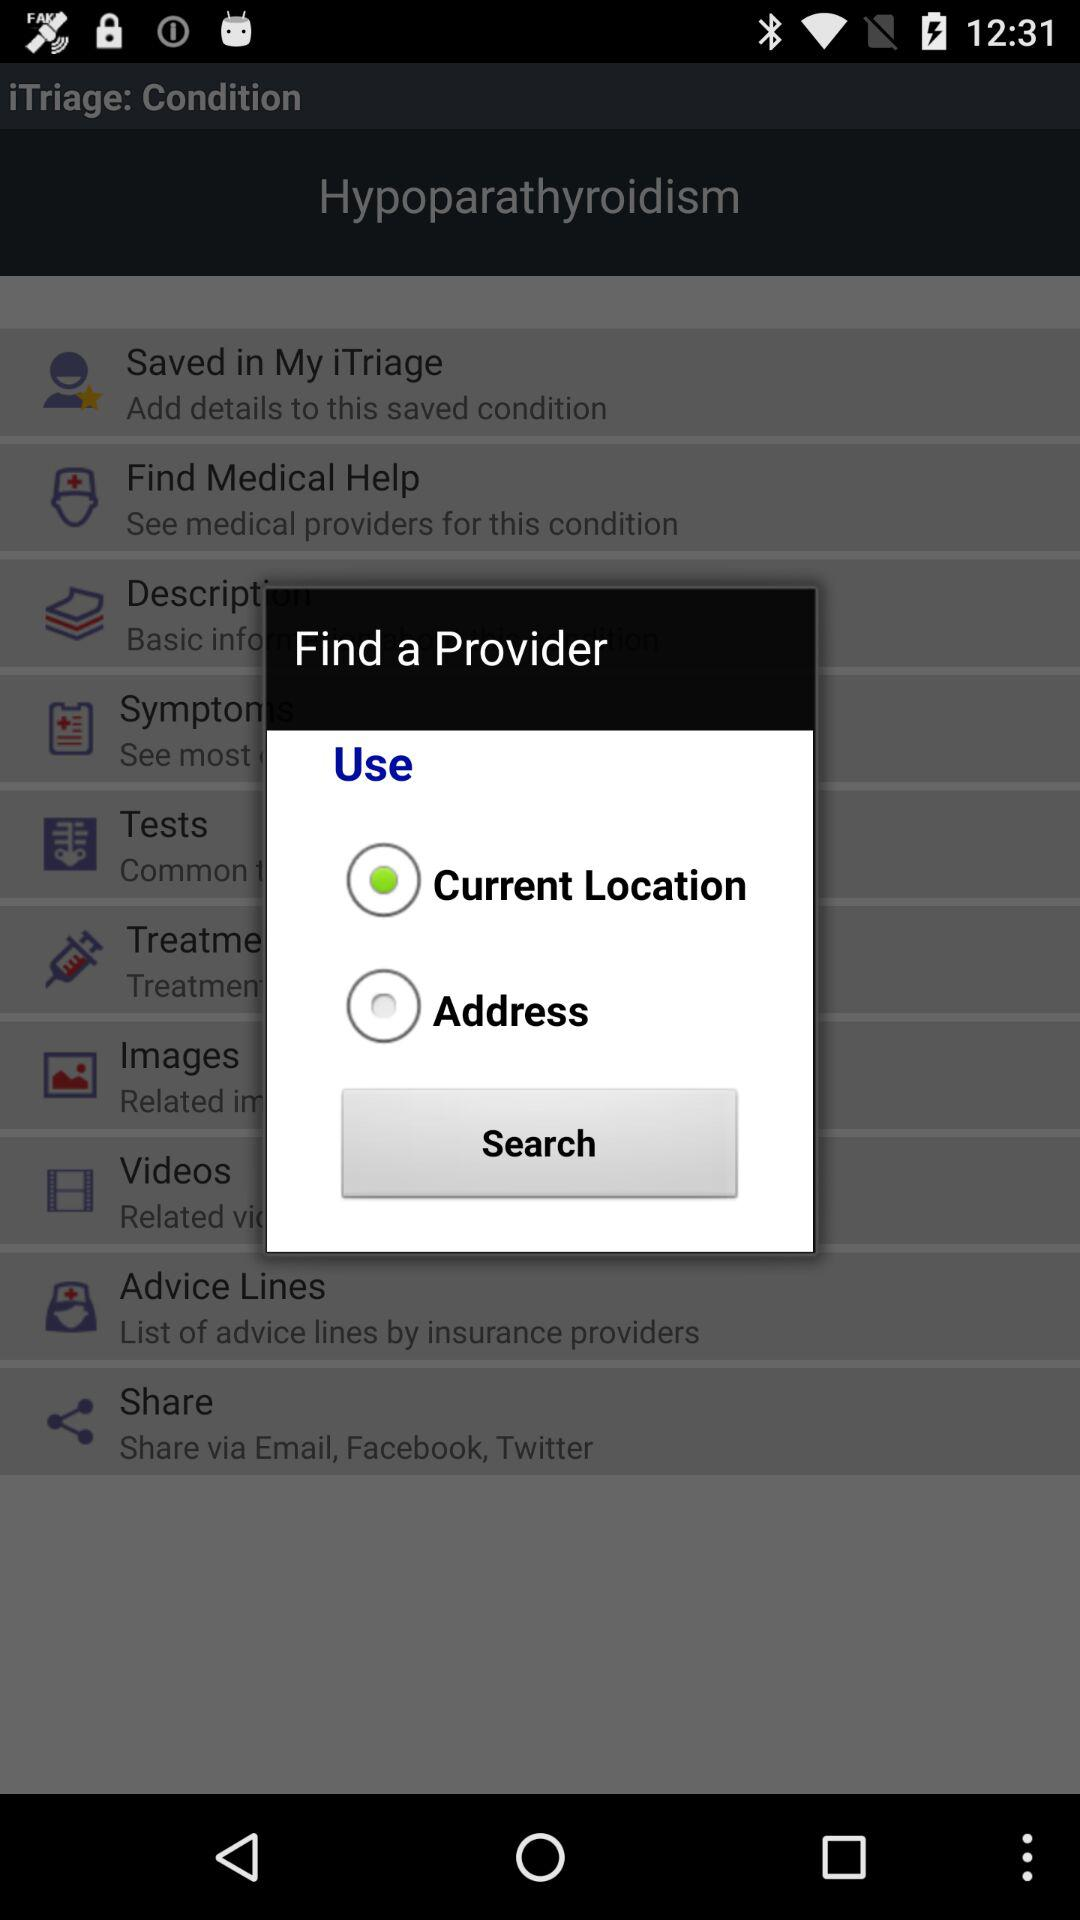Is "Current Location" selected or not? "Current Location" is selected. 